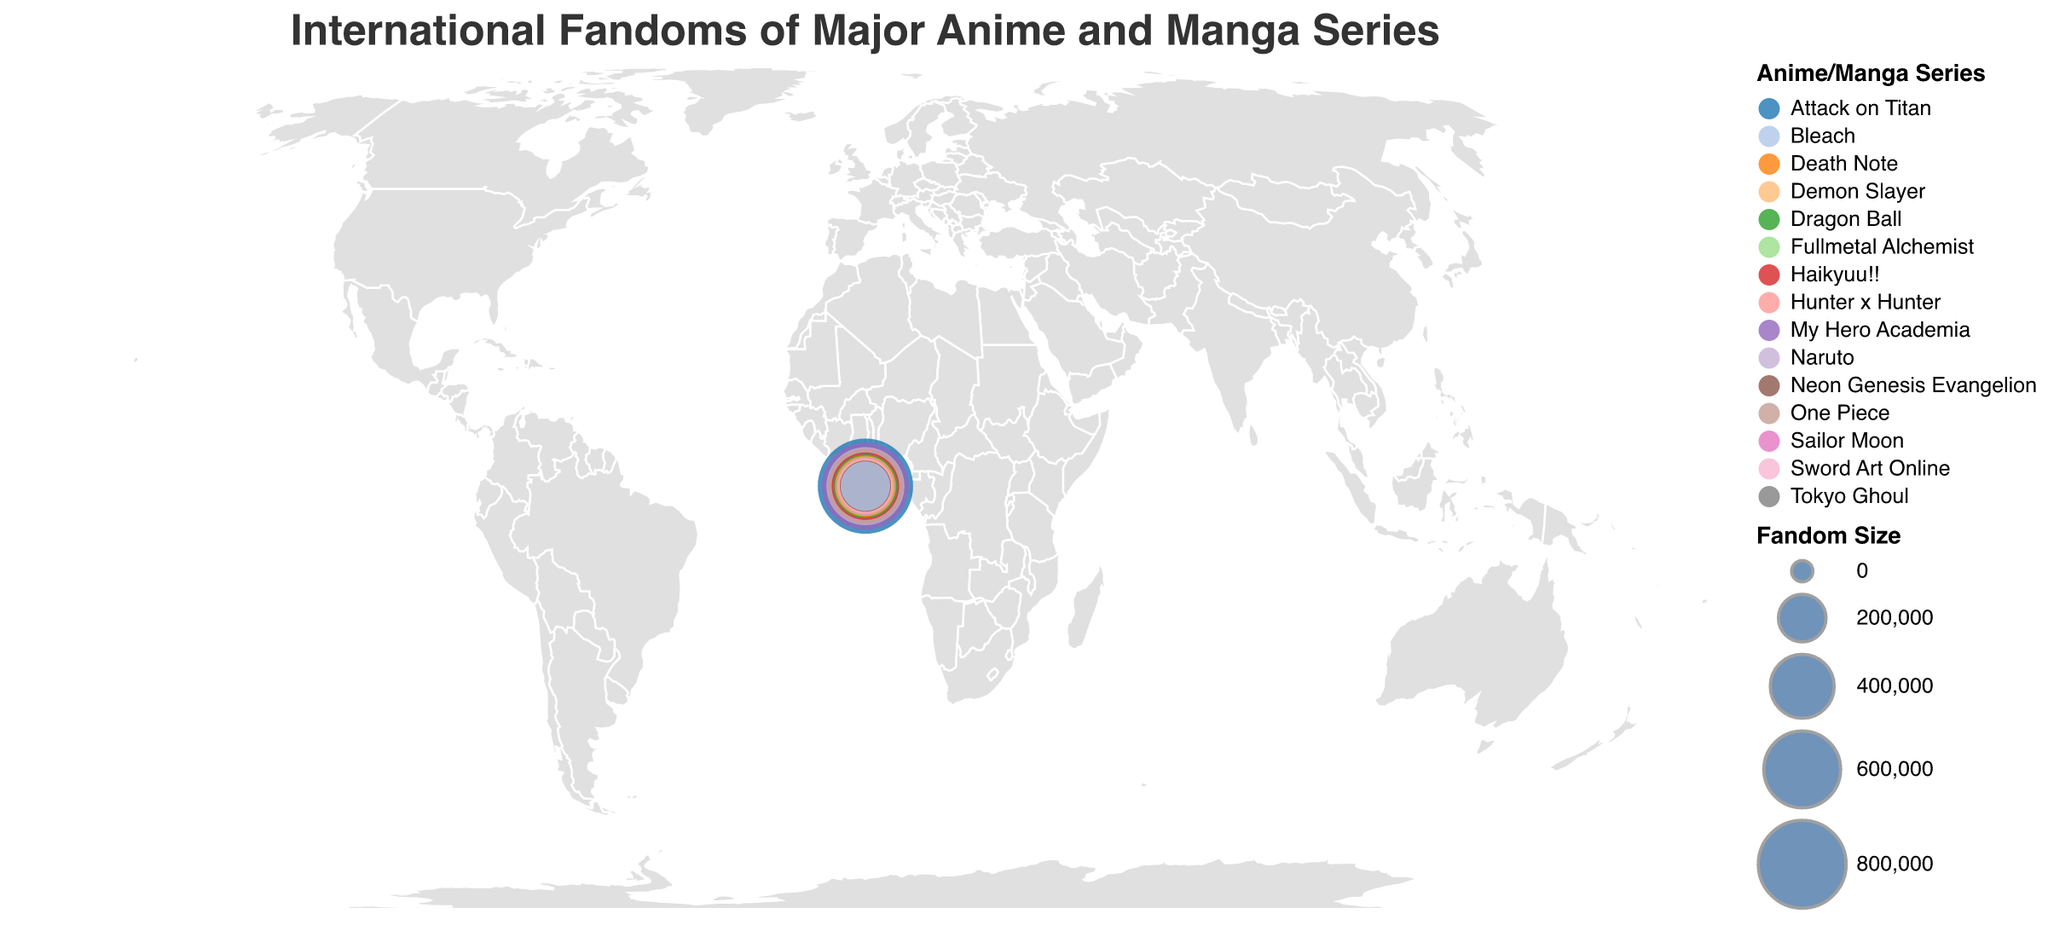What is the title of the plot? The title is usually located at the top of the plot. According to the code provided, the title is specified as "International Fandoms of Major Anime and Manga Series."
Answer: International Fandoms of Major Anime and Manga Series Which country has the largest fandom size for an anime or manga series? To find this, compare the fandom sizes for each country. According to the data, Japan has the largest fandom size with 950,000 for "Attack on Titan."
Answer: Japan What series is most popular in the United States? Check the data for the United States. The series listed for this country is "My Hero Academia."
Answer: My Hero Academia How many different anime or manga series are represented in this plot? Count the unique values in the "Series" field from the data. The series listed are: Attack on Titan, My Hero Academia, Naruto, One Piece, Haikyuu!!, Tokyo Ghoul, Dragon Ball, Death Note, Fullmetal Alchemist, Sailor Moon, Demon Slayer, Hunter x Hunter, Sword Art Online, Neon Genesis Evangelion, and Bleach, making it 15 series.
Answer: 15 Which country has the smallest fandom size, and what is the size? To find the smallest fandom size, compare the sizes across all countries. According to the data, Thailand has the smallest fandom size with 220,000 for "Bleach."
Answer: Thailand, 220000 What is the total fandom size for all the countries combined? Sum the fandom sizes of all countries: 950,000 + 780,000 + 620,000 + 580,000 + 450,000 + 410,000 + 390,000 + 370,000 + 340,000 + 320,000 + 300,000 + 280,000 + 260,000 + 240,000 + 220,000 = 6,510,000.
Answer: 6,510,000 Which series is most popular in European countries, and which countries are they? Look for European countries in the data: France, United Kingdom, Germany, Spain, and Italy. Then find the associated series with the largest fandom size among these countries. The series listed are: One Piece (France, 580,000), Death Note (United Kingdom, 370,000), Fullmetal Alchemist (Germany, 340,000), Hunter x Hunter (Spain, 280,000), Sword Art Online (Italy, 260,000). The largest size is for "One Piece" in France with 580,000.
Answer: One Piece in France Which country has a larger fandom for "Tokyo Ghoul," Indonesia or Mexico? Check the fandom sizes for "Tokyo Ghoul" and compare. Indonesia has a fandom size of 410,000 for "Tokyo Ghoul," and Mexico's fandom size for "Tokyo Ghoul" is not listed. Hence, Indonesia has the larger fandom for "Tokyo Ghoul."
Answer: Indonesia What is the average fandom size for anime and manga in Asian countries listed? Asian countries in the data are Japan, Philippines, Indonesia, South Korea, Thailand. Their fandom sizes are: 950,000 + 450,000 + 410,000 + 300,000 + 220,000. Average = (950,000 + 450,000 + 410,000 + 300,000 + 220,000) / 5 = 2,330,000 / 5 = 466,000.
Answer: 466,000 Which two series have the closest fandom sizes according to the data? Compare the fandom sizes from the data. The two closest sizes are "Death Note" in the United Kingdom with 370,000 and "Fullmetal Alchemist" in Germany with 340,000, which have a difference of 30,000.
Answer: Death Note and Fullmetal Alchemist 